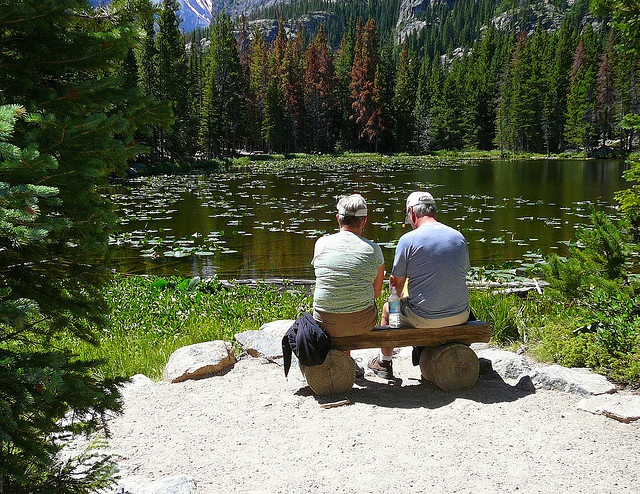Describe the objects in this image and their specific colors. I can see people in black, gray, white, and darkgray tones, people in black, white, gray, olive, and maroon tones, bench in black, maroon, and gray tones, and bottle in black, darkgray, white, gray, and teal tones in this image. 